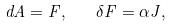<formula> <loc_0><loc_0><loc_500><loc_500>d A = F , \quad \delta F = \alpha J ,</formula> 